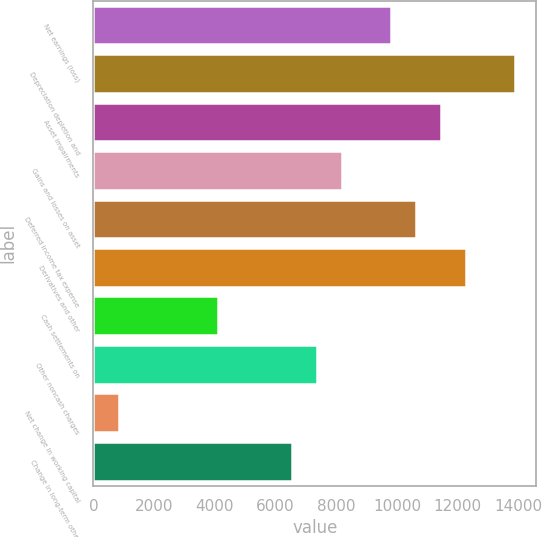Convert chart to OTSL. <chart><loc_0><loc_0><loc_500><loc_500><bar_chart><fcel>Net earnings (loss)<fcel>Depreciation depletion and<fcel>Asset impairments<fcel>Gains and losses on asset<fcel>Deferred income tax expense<fcel>Derivatives and other<fcel>Cash settlements on<fcel>Other noncash charges<fcel>Net change in working capital<fcel>Change in long-term other<nl><fcel>9815<fcel>13892.5<fcel>11446<fcel>8184<fcel>10630.5<fcel>12261.5<fcel>4106.5<fcel>7368.5<fcel>844.5<fcel>6553<nl></chart> 